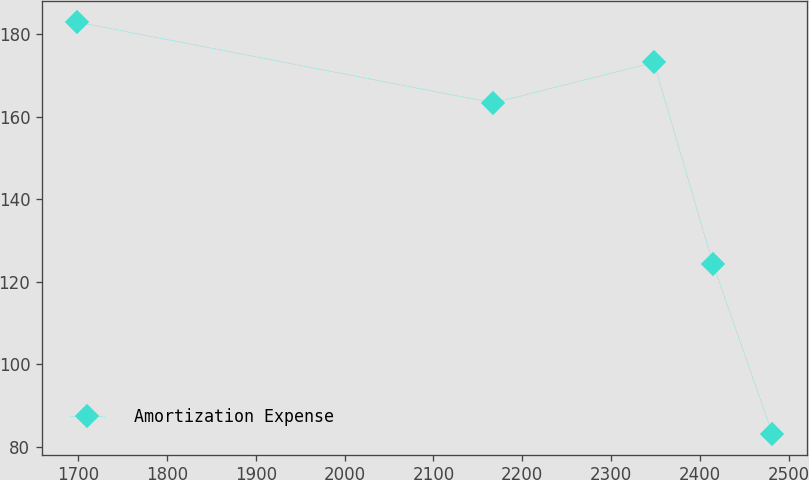Convert chart to OTSL. <chart><loc_0><loc_0><loc_500><loc_500><line_chart><ecel><fcel>Amortization Expense<nl><fcel>1698.22<fcel>182.92<nl><fcel>2167.58<fcel>163.3<nl><fcel>2348.24<fcel>173.11<nl><fcel>2415.01<fcel>124.15<nl><fcel>2481.78<fcel>83.02<nl></chart> 